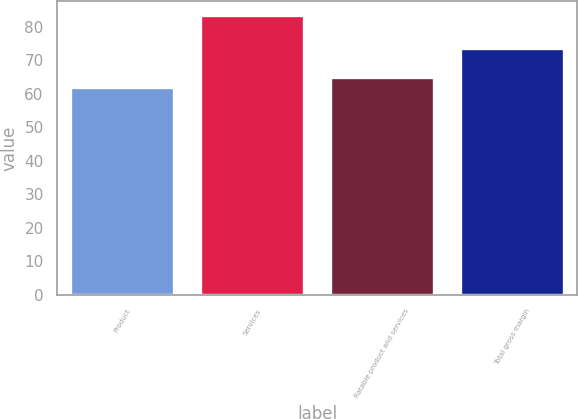Convert chart to OTSL. <chart><loc_0><loc_0><loc_500><loc_500><bar_chart><fcel>Product<fcel>Services<fcel>Ratable product and services<fcel>Total gross margin<nl><fcel>61.9<fcel>83.4<fcel>64.8<fcel>73.6<nl></chart> 